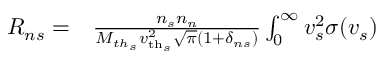Convert formula to latex. <formula><loc_0><loc_0><loc_500><loc_500>\begin{array} { r l } { R _ { n s } = } & \frac { n _ { s } n _ { n } } { M _ { t h _ { s } } { v _ { t h _ { s } } } ^ { 2 } \sqrt { \pi } ( 1 + \delta _ { n s } ) } \int _ { 0 } ^ { \infty } v _ { s } ^ { 2 } \sigma ( v _ { s } ) } \end{array}</formula> 